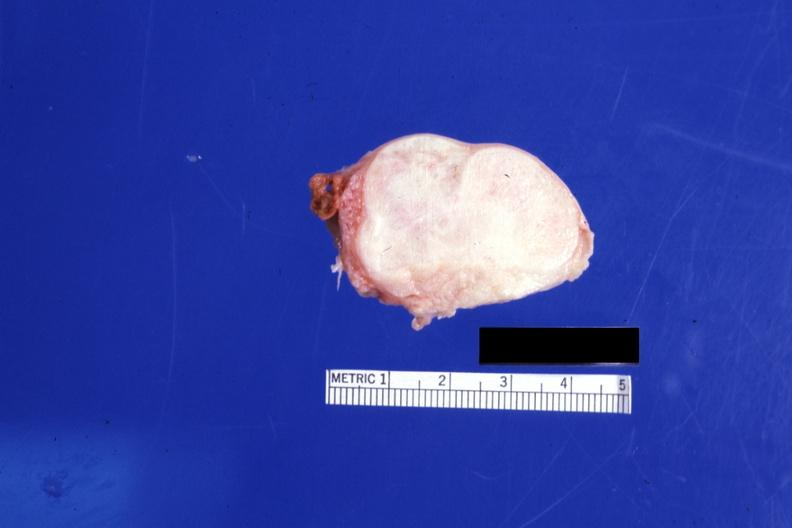what does this image show?
Answer the question using a single word or phrase. Cut surface 4 cm lesion 76yobf 